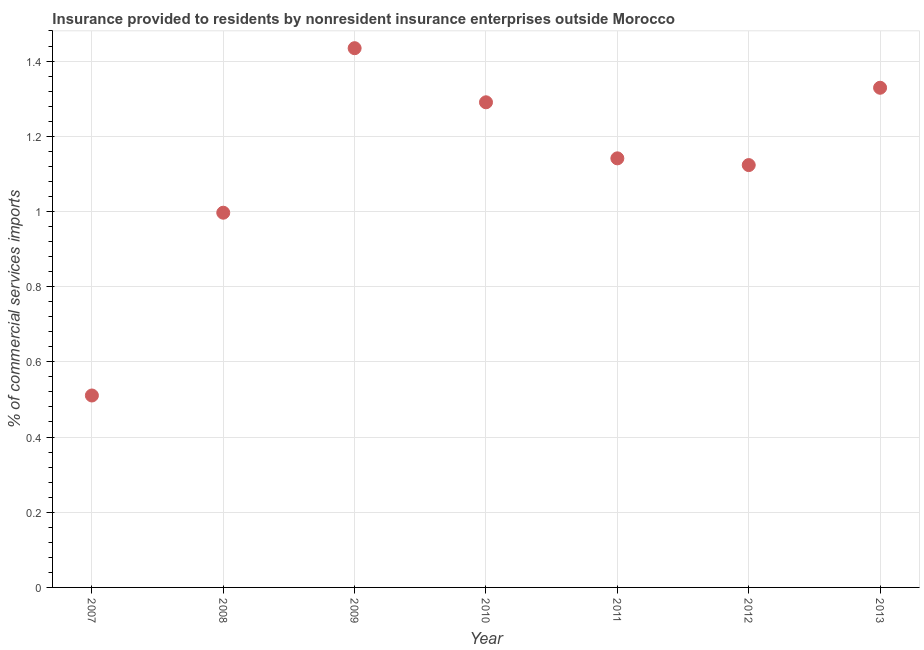What is the insurance provided by non-residents in 2011?
Your answer should be very brief. 1.14. Across all years, what is the maximum insurance provided by non-residents?
Offer a terse response. 1.43. Across all years, what is the minimum insurance provided by non-residents?
Your answer should be very brief. 0.51. In which year was the insurance provided by non-residents maximum?
Make the answer very short. 2009. What is the sum of the insurance provided by non-residents?
Make the answer very short. 7.83. What is the difference between the insurance provided by non-residents in 2009 and 2012?
Your response must be concise. 0.31. What is the average insurance provided by non-residents per year?
Your answer should be compact. 1.12. What is the median insurance provided by non-residents?
Your answer should be very brief. 1.14. In how many years, is the insurance provided by non-residents greater than 0.92 %?
Offer a very short reply. 6. Do a majority of the years between 2009 and 2008 (inclusive) have insurance provided by non-residents greater than 1 %?
Offer a very short reply. No. What is the ratio of the insurance provided by non-residents in 2010 to that in 2012?
Provide a short and direct response. 1.15. Is the insurance provided by non-residents in 2009 less than that in 2010?
Keep it short and to the point. No. Is the difference between the insurance provided by non-residents in 2010 and 2012 greater than the difference between any two years?
Your response must be concise. No. What is the difference between the highest and the second highest insurance provided by non-residents?
Your response must be concise. 0.11. What is the difference between the highest and the lowest insurance provided by non-residents?
Make the answer very short. 0.92. How many dotlines are there?
Give a very brief answer. 1. How many years are there in the graph?
Ensure brevity in your answer.  7. What is the difference between two consecutive major ticks on the Y-axis?
Make the answer very short. 0.2. Does the graph contain grids?
Offer a terse response. Yes. What is the title of the graph?
Give a very brief answer. Insurance provided to residents by nonresident insurance enterprises outside Morocco. What is the label or title of the X-axis?
Ensure brevity in your answer.  Year. What is the label or title of the Y-axis?
Ensure brevity in your answer.  % of commercial services imports. What is the % of commercial services imports in 2007?
Provide a succinct answer. 0.51. What is the % of commercial services imports in 2008?
Provide a succinct answer. 1. What is the % of commercial services imports in 2009?
Your answer should be compact. 1.43. What is the % of commercial services imports in 2010?
Offer a terse response. 1.29. What is the % of commercial services imports in 2011?
Keep it short and to the point. 1.14. What is the % of commercial services imports in 2012?
Offer a very short reply. 1.12. What is the % of commercial services imports in 2013?
Offer a very short reply. 1.33. What is the difference between the % of commercial services imports in 2007 and 2008?
Offer a very short reply. -0.49. What is the difference between the % of commercial services imports in 2007 and 2009?
Your answer should be very brief. -0.92. What is the difference between the % of commercial services imports in 2007 and 2010?
Offer a very short reply. -0.78. What is the difference between the % of commercial services imports in 2007 and 2011?
Make the answer very short. -0.63. What is the difference between the % of commercial services imports in 2007 and 2012?
Make the answer very short. -0.61. What is the difference between the % of commercial services imports in 2007 and 2013?
Your response must be concise. -0.82. What is the difference between the % of commercial services imports in 2008 and 2009?
Your response must be concise. -0.44. What is the difference between the % of commercial services imports in 2008 and 2010?
Provide a short and direct response. -0.29. What is the difference between the % of commercial services imports in 2008 and 2011?
Offer a terse response. -0.14. What is the difference between the % of commercial services imports in 2008 and 2012?
Make the answer very short. -0.13. What is the difference between the % of commercial services imports in 2008 and 2013?
Ensure brevity in your answer.  -0.33. What is the difference between the % of commercial services imports in 2009 and 2010?
Provide a succinct answer. 0.14. What is the difference between the % of commercial services imports in 2009 and 2011?
Offer a terse response. 0.29. What is the difference between the % of commercial services imports in 2009 and 2012?
Keep it short and to the point. 0.31. What is the difference between the % of commercial services imports in 2009 and 2013?
Provide a short and direct response. 0.11. What is the difference between the % of commercial services imports in 2010 and 2011?
Give a very brief answer. 0.15. What is the difference between the % of commercial services imports in 2010 and 2012?
Provide a short and direct response. 0.17. What is the difference between the % of commercial services imports in 2010 and 2013?
Keep it short and to the point. -0.04. What is the difference between the % of commercial services imports in 2011 and 2012?
Keep it short and to the point. 0.02. What is the difference between the % of commercial services imports in 2011 and 2013?
Ensure brevity in your answer.  -0.19. What is the difference between the % of commercial services imports in 2012 and 2013?
Your response must be concise. -0.21. What is the ratio of the % of commercial services imports in 2007 to that in 2008?
Your response must be concise. 0.51. What is the ratio of the % of commercial services imports in 2007 to that in 2009?
Provide a short and direct response. 0.36. What is the ratio of the % of commercial services imports in 2007 to that in 2010?
Your answer should be very brief. 0.4. What is the ratio of the % of commercial services imports in 2007 to that in 2011?
Your response must be concise. 0.45. What is the ratio of the % of commercial services imports in 2007 to that in 2012?
Your answer should be very brief. 0.45. What is the ratio of the % of commercial services imports in 2007 to that in 2013?
Provide a short and direct response. 0.38. What is the ratio of the % of commercial services imports in 2008 to that in 2009?
Ensure brevity in your answer.  0.69. What is the ratio of the % of commercial services imports in 2008 to that in 2010?
Make the answer very short. 0.77. What is the ratio of the % of commercial services imports in 2008 to that in 2011?
Offer a very short reply. 0.87. What is the ratio of the % of commercial services imports in 2008 to that in 2012?
Offer a very short reply. 0.89. What is the ratio of the % of commercial services imports in 2008 to that in 2013?
Provide a short and direct response. 0.75. What is the ratio of the % of commercial services imports in 2009 to that in 2010?
Your answer should be compact. 1.11. What is the ratio of the % of commercial services imports in 2009 to that in 2011?
Your answer should be very brief. 1.26. What is the ratio of the % of commercial services imports in 2009 to that in 2012?
Ensure brevity in your answer.  1.28. What is the ratio of the % of commercial services imports in 2009 to that in 2013?
Keep it short and to the point. 1.08. What is the ratio of the % of commercial services imports in 2010 to that in 2011?
Provide a succinct answer. 1.13. What is the ratio of the % of commercial services imports in 2010 to that in 2012?
Give a very brief answer. 1.15. What is the ratio of the % of commercial services imports in 2010 to that in 2013?
Offer a very short reply. 0.97. What is the ratio of the % of commercial services imports in 2011 to that in 2013?
Your response must be concise. 0.86. What is the ratio of the % of commercial services imports in 2012 to that in 2013?
Give a very brief answer. 0.84. 